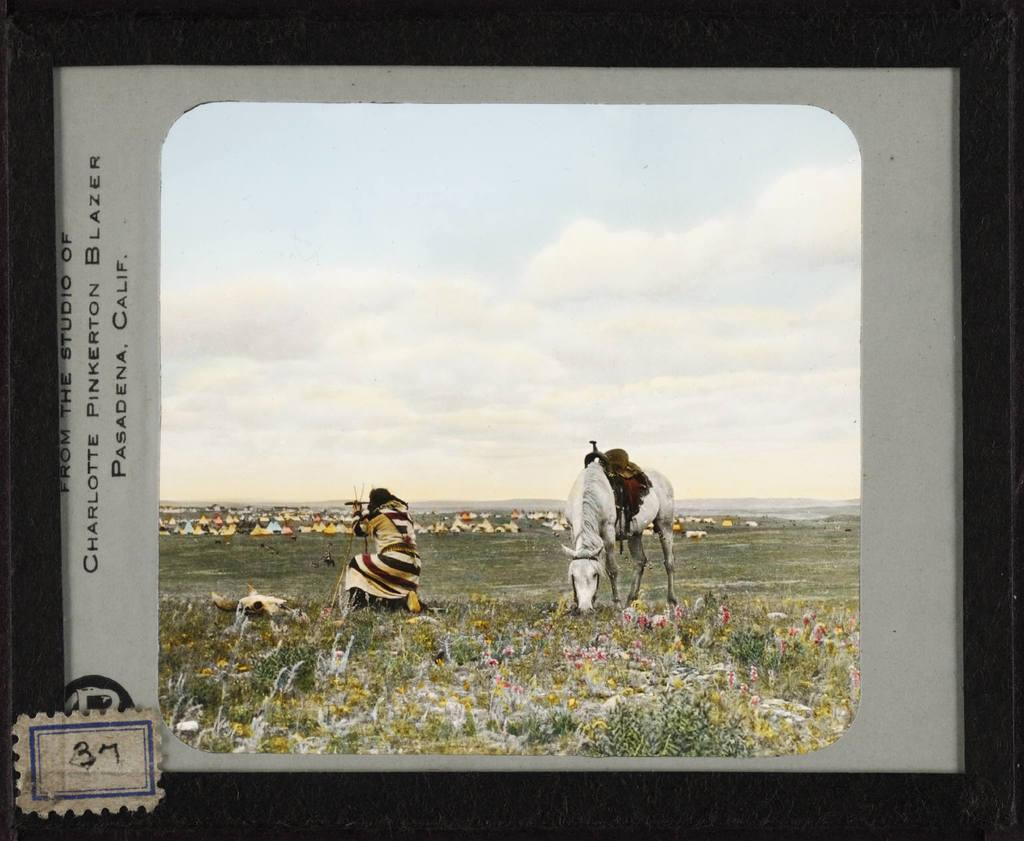<image>
Summarize the visual content of the image. Postercard showing a woman and a horse and the number 37 near the bottom. 